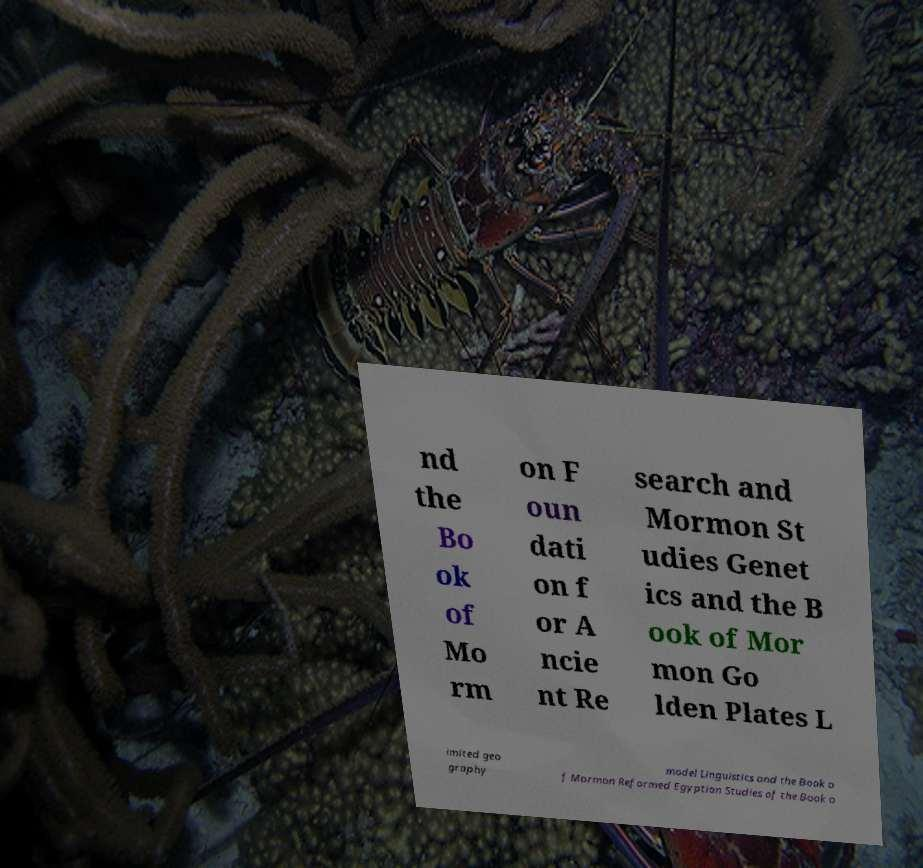Can you accurately transcribe the text from the provided image for me? nd the Bo ok of Mo rm on F oun dati on f or A ncie nt Re search and Mormon St udies Genet ics and the B ook of Mor mon Go lden Plates L imited geo graphy model Linguistics and the Book o f Mormon Reformed Egyptian Studies of the Book o 